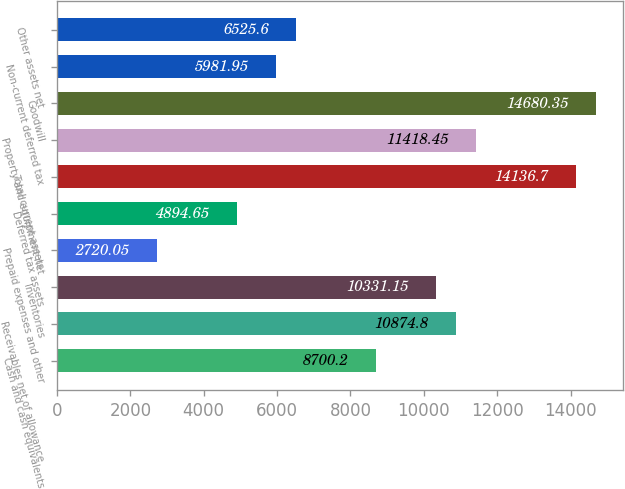Convert chart to OTSL. <chart><loc_0><loc_0><loc_500><loc_500><bar_chart><fcel>Cash and cash equivalents<fcel>Receivables net of allowance<fcel>Inventories<fcel>Prepaid expenses and other<fcel>Deferred tax assets<fcel>Total current assets<fcel>Property and equipment net<fcel>Goodwill<fcel>Non-current deferred tax<fcel>Other assets net<nl><fcel>8700.2<fcel>10874.8<fcel>10331.1<fcel>2720.05<fcel>4894.65<fcel>14136.7<fcel>11418.5<fcel>14680.4<fcel>5981.95<fcel>6525.6<nl></chart> 